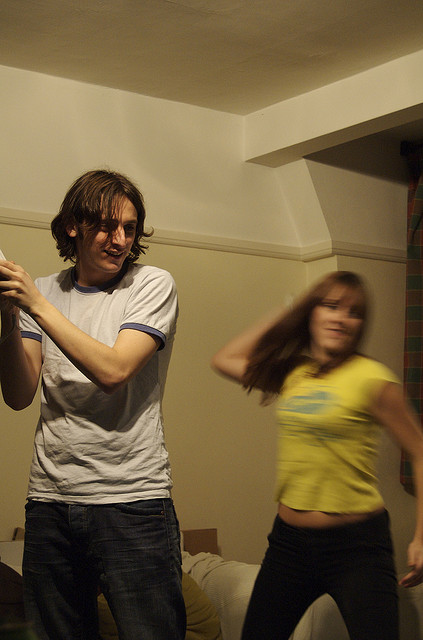<image>What color tags do the women playing the game have? It is unclear what color tags the women playing the game have. The tags could be yellow, white, black, or none at all. What color tags do the women playing the game have? I am not sure what color tags do the women playing the game have. It can be seen yellow, white, black or white shirt. 